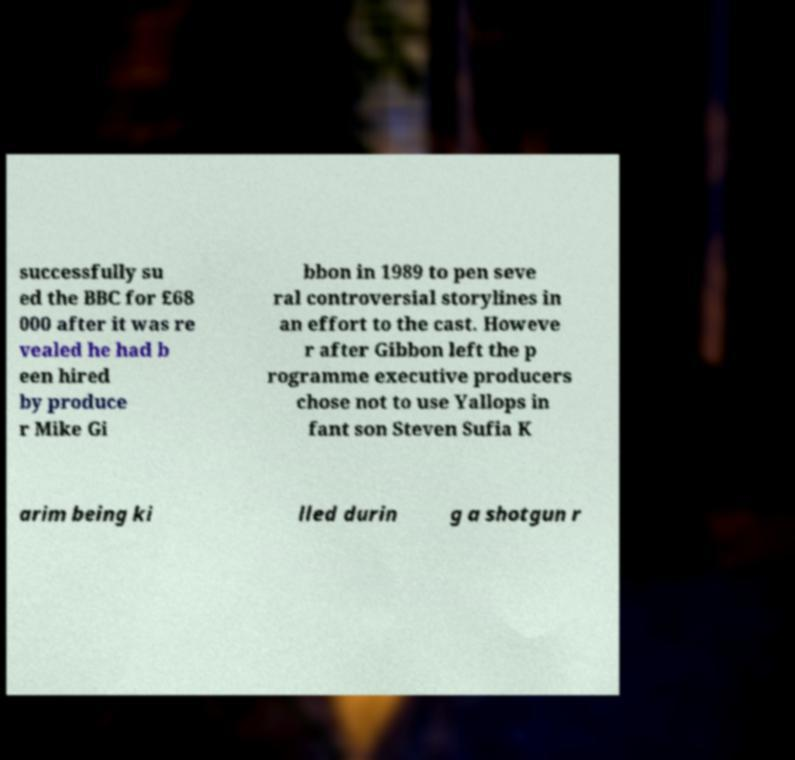Please read and relay the text visible in this image. What does it say? successfully su ed the BBC for £68 000 after it was re vealed he had b een hired by produce r Mike Gi bbon in 1989 to pen seve ral controversial storylines in an effort to the cast. Howeve r after Gibbon left the p rogramme executive producers chose not to use Yallops in fant son Steven Sufia K arim being ki lled durin g a shotgun r 